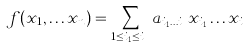<formula> <loc_0><loc_0><loc_500><loc_500>f ( x _ { 1 } , \dots x _ { n } ) = \sum _ { 1 \leq i _ { 1 } \dots \leq i _ { k } } a _ { i _ { 1 } \dots i _ { k } } x _ { i _ { 1 } } \dots x _ { i _ { k } }</formula> 